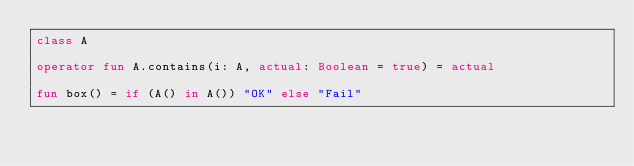Convert code to text. <code><loc_0><loc_0><loc_500><loc_500><_Kotlin_>class A

operator fun A.contains(i: A, actual: Boolean = true) = actual

fun box() = if (A() in A()) "OK" else "Fail"
</code> 